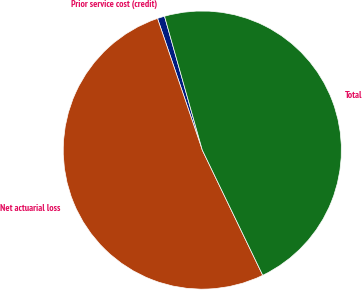Convert chart. <chart><loc_0><loc_0><loc_500><loc_500><pie_chart><fcel>Prior service cost (credit)<fcel>Net actuarial loss<fcel>Total<nl><fcel>0.84%<fcel>51.94%<fcel>47.22%<nl></chart> 